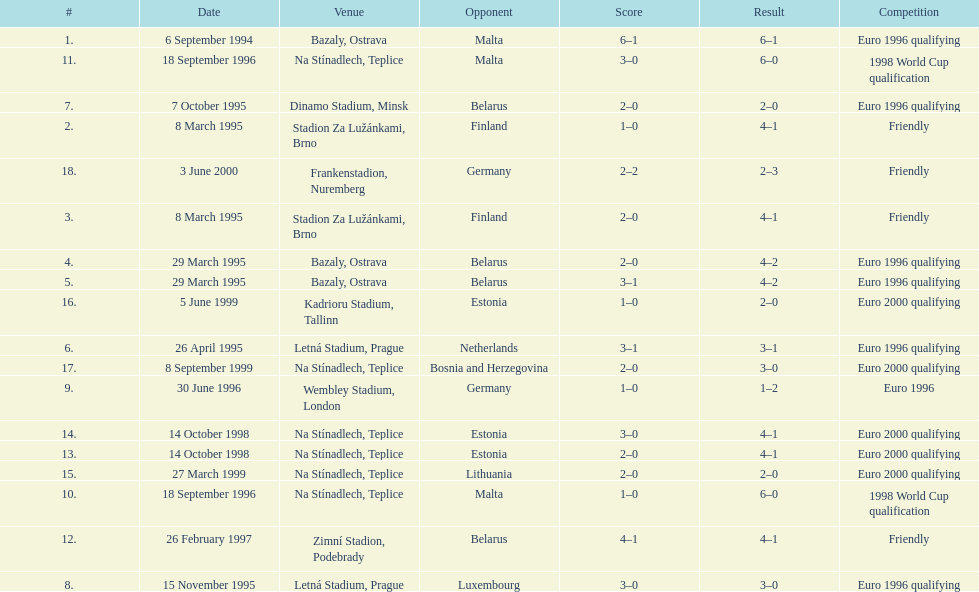Which team did czech republic score the most goals against? Malta. 